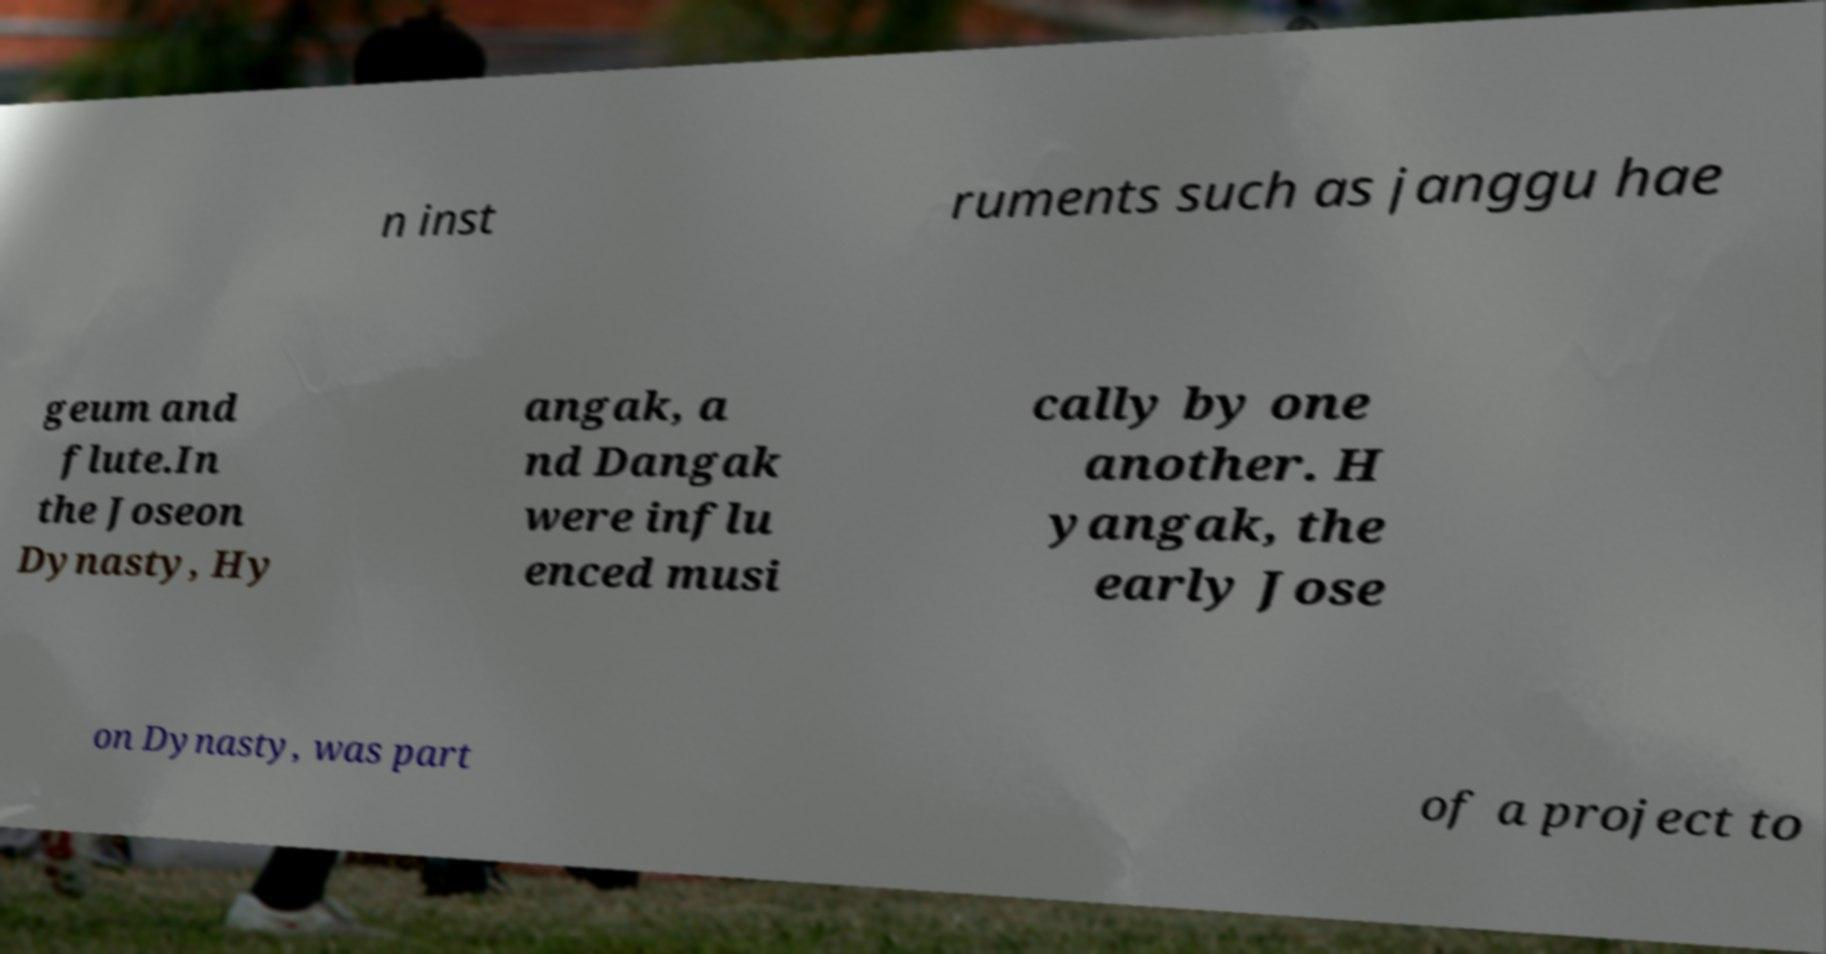There's text embedded in this image that I need extracted. Can you transcribe it verbatim? n inst ruments such as janggu hae geum and flute.In the Joseon Dynasty, Hy angak, a nd Dangak were influ enced musi cally by one another. H yangak, the early Jose on Dynasty, was part of a project to 